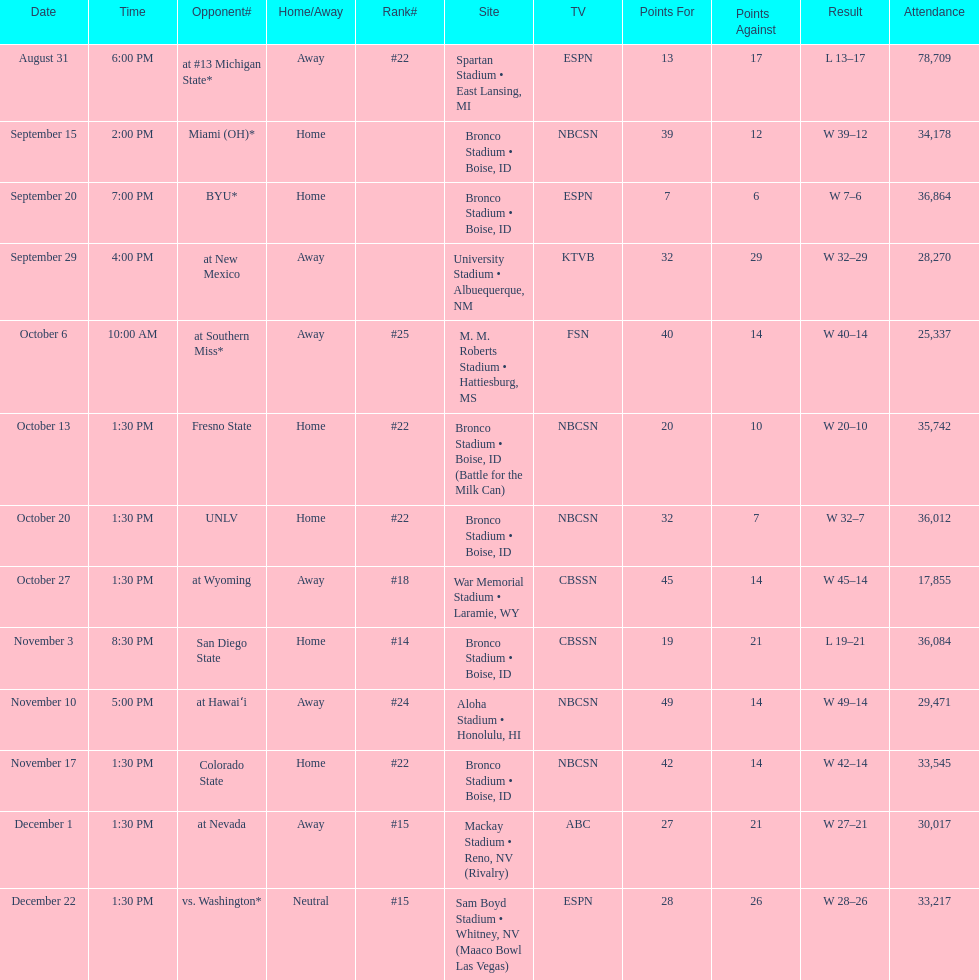What is the complete sum of games played at bronco stadium? 6. 